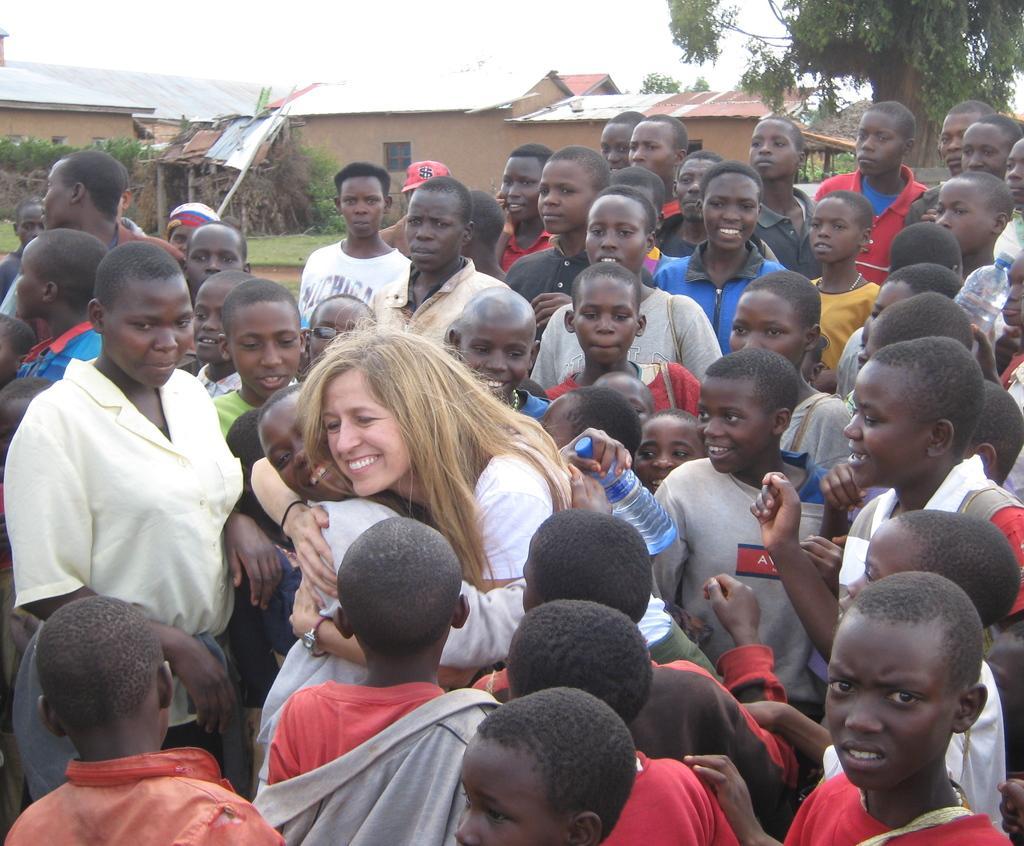Describe this image in one or two sentences. In this picture there are group of people standing and there is a woman standing and smiling and hugging the boy. At the back there are houses and trees. At the top there is sky. At the bottom there is grass. 